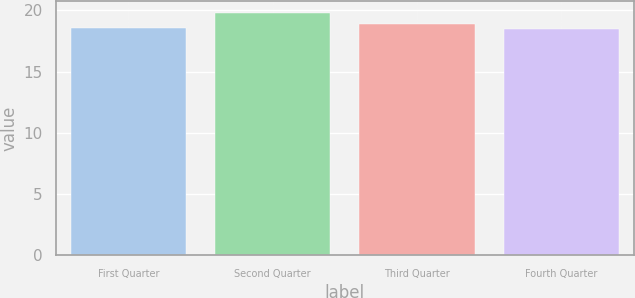Convert chart. <chart><loc_0><loc_0><loc_500><loc_500><bar_chart><fcel>First Quarter<fcel>Second Quarter<fcel>Third Quarter<fcel>Fourth Quarter<nl><fcel>18.59<fcel>19.76<fcel>18.9<fcel>18.46<nl></chart> 